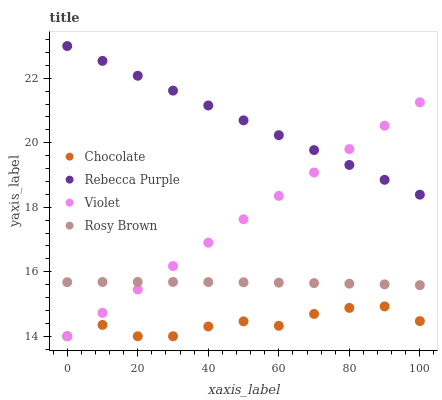Does Chocolate have the minimum area under the curve?
Answer yes or no. Yes. Does Rebecca Purple have the maximum area under the curve?
Answer yes or no. Yes. Does Violet have the minimum area under the curve?
Answer yes or no. No. Does Violet have the maximum area under the curve?
Answer yes or no. No. Is Rebecca Purple the smoothest?
Answer yes or no. Yes. Is Chocolate the roughest?
Answer yes or no. Yes. Is Violet the smoothest?
Answer yes or no. No. Is Violet the roughest?
Answer yes or no. No. Does Violet have the lowest value?
Answer yes or no. Yes. Does Rebecca Purple have the lowest value?
Answer yes or no. No. Does Rebecca Purple have the highest value?
Answer yes or no. Yes. Does Violet have the highest value?
Answer yes or no. No. Is Chocolate less than Rosy Brown?
Answer yes or no. Yes. Is Rosy Brown greater than Chocolate?
Answer yes or no. Yes. Does Violet intersect Rebecca Purple?
Answer yes or no. Yes. Is Violet less than Rebecca Purple?
Answer yes or no. No. Is Violet greater than Rebecca Purple?
Answer yes or no. No. Does Chocolate intersect Rosy Brown?
Answer yes or no. No. 